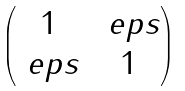<formula> <loc_0><loc_0><loc_500><loc_500>\begin{pmatrix} 1 & \ e p s \\ \ e p s & 1 \end{pmatrix}</formula> 